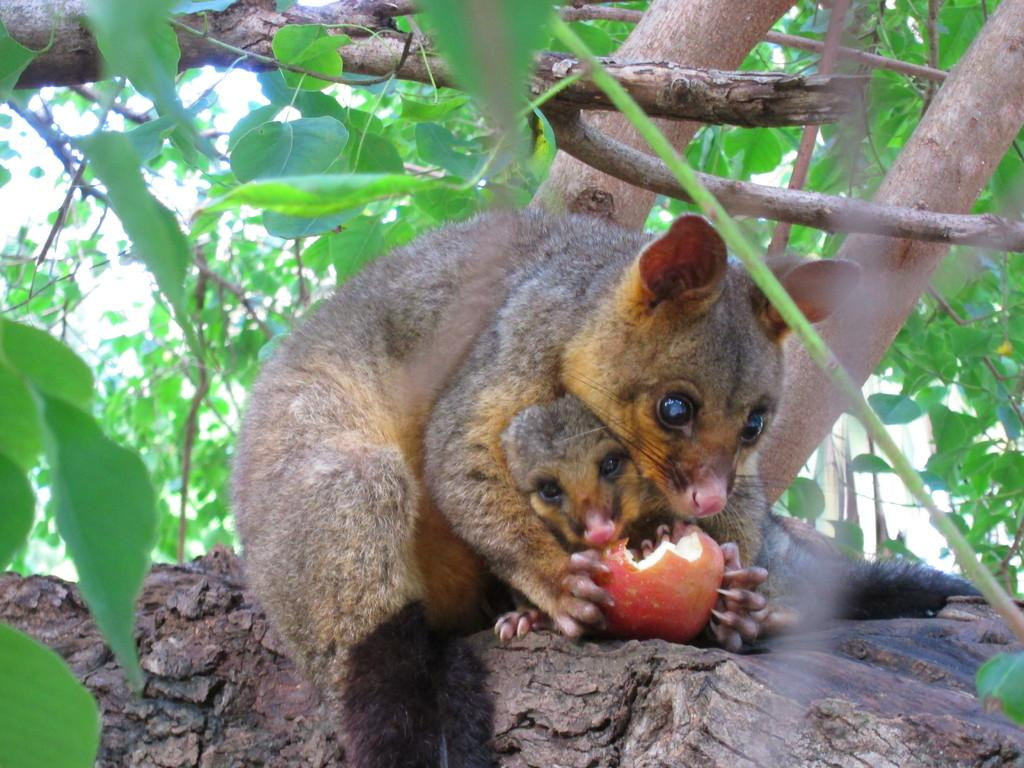What type of animal is in the image? There is a fox squirrel in the image. Is there more than one fox squirrel in the image? Yes, there is a baby fox squirrel in the image as well. Where are the fox squirrels located in the image? Both fox squirrels are on a tree. What is the fox squirrel holding in the image? The fox squirrel is holding a fruit. What can be seen in the background of the image? Leaves are visible in the image. What colors are the fox squirrels? The fox squirrels are black and brown in color. What type of harbor can be seen in the image? There is no harbor present in the image; it features a fox squirrel and a baby fox squirrel on a tree. What is the fox squirrel writing in its notebook in the image? There is no notebook present in the image, and the fox squirrel is not shown writing anything. 